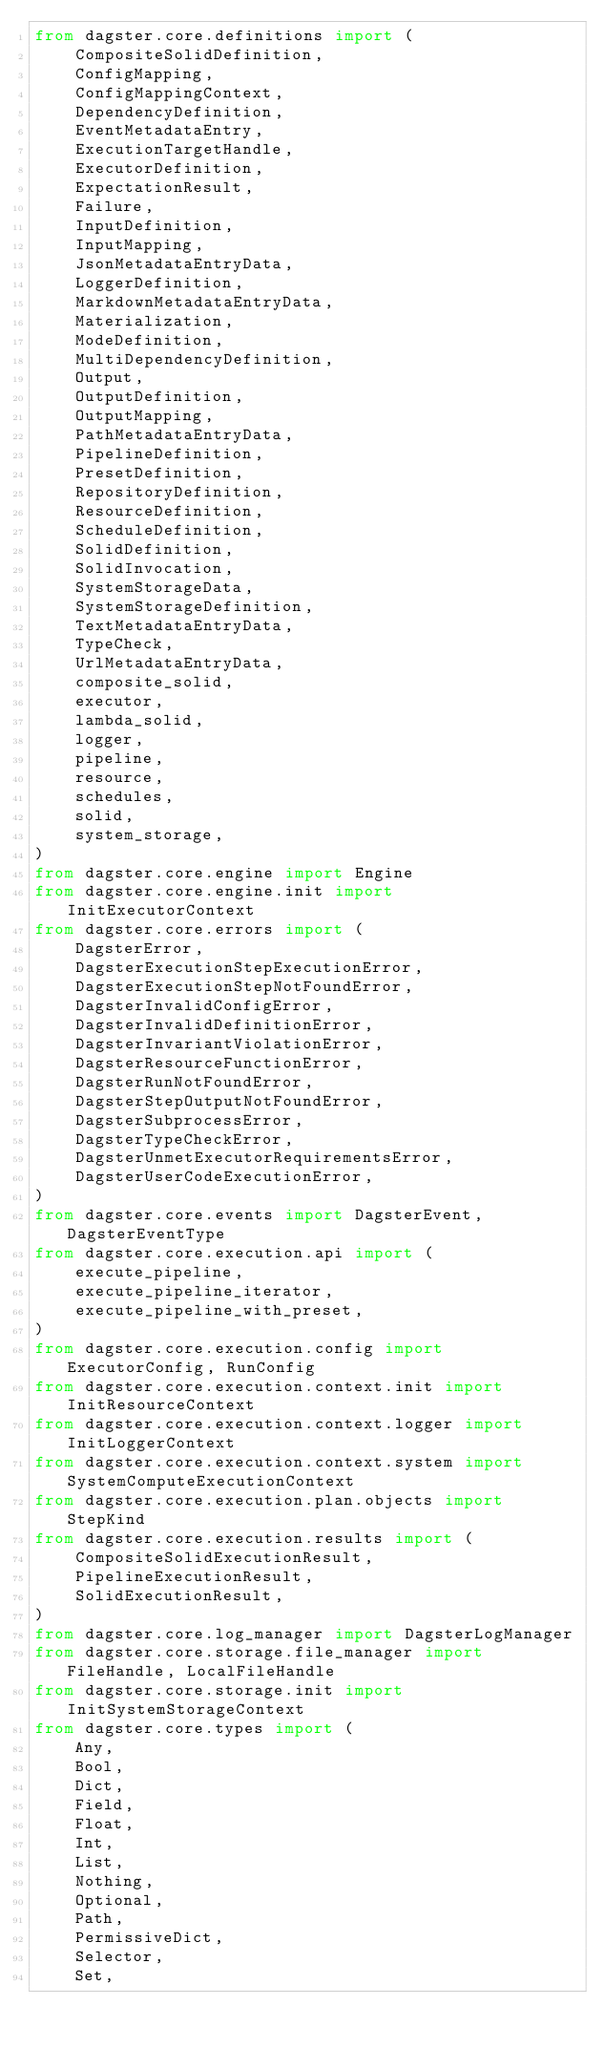<code> <loc_0><loc_0><loc_500><loc_500><_Python_>from dagster.core.definitions import (
    CompositeSolidDefinition,
    ConfigMapping,
    ConfigMappingContext,
    DependencyDefinition,
    EventMetadataEntry,
    ExecutionTargetHandle,
    ExecutorDefinition,
    ExpectationResult,
    Failure,
    InputDefinition,
    InputMapping,
    JsonMetadataEntryData,
    LoggerDefinition,
    MarkdownMetadataEntryData,
    Materialization,
    ModeDefinition,
    MultiDependencyDefinition,
    Output,
    OutputDefinition,
    OutputMapping,
    PathMetadataEntryData,
    PipelineDefinition,
    PresetDefinition,
    RepositoryDefinition,
    ResourceDefinition,
    ScheduleDefinition,
    SolidDefinition,
    SolidInvocation,
    SystemStorageData,
    SystemStorageDefinition,
    TextMetadataEntryData,
    TypeCheck,
    UrlMetadataEntryData,
    composite_solid,
    executor,
    lambda_solid,
    logger,
    pipeline,
    resource,
    schedules,
    solid,
    system_storage,
)
from dagster.core.engine import Engine
from dagster.core.engine.init import InitExecutorContext
from dagster.core.errors import (
    DagsterError,
    DagsterExecutionStepExecutionError,
    DagsterExecutionStepNotFoundError,
    DagsterInvalidConfigError,
    DagsterInvalidDefinitionError,
    DagsterInvariantViolationError,
    DagsterResourceFunctionError,
    DagsterRunNotFoundError,
    DagsterStepOutputNotFoundError,
    DagsterSubprocessError,
    DagsterTypeCheckError,
    DagsterUnmetExecutorRequirementsError,
    DagsterUserCodeExecutionError,
)
from dagster.core.events import DagsterEvent, DagsterEventType
from dagster.core.execution.api import (
    execute_pipeline,
    execute_pipeline_iterator,
    execute_pipeline_with_preset,
)
from dagster.core.execution.config import ExecutorConfig, RunConfig
from dagster.core.execution.context.init import InitResourceContext
from dagster.core.execution.context.logger import InitLoggerContext
from dagster.core.execution.context.system import SystemComputeExecutionContext
from dagster.core.execution.plan.objects import StepKind
from dagster.core.execution.results import (
    CompositeSolidExecutionResult,
    PipelineExecutionResult,
    SolidExecutionResult,
)
from dagster.core.log_manager import DagsterLogManager
from dagster.core.storage.file_manager import FileHandle, LocalFileHandle
from dagster.core.storage.init import InitSystemStorageContext
from dagster.core.types import (
    Any,
    Bool,
    Dict,
    Field,
    Float,
    Int,
    List,
    Nothing,
    Optional,
    Path,
    PermissiveDict,
    Selector,
    Set,</code> 